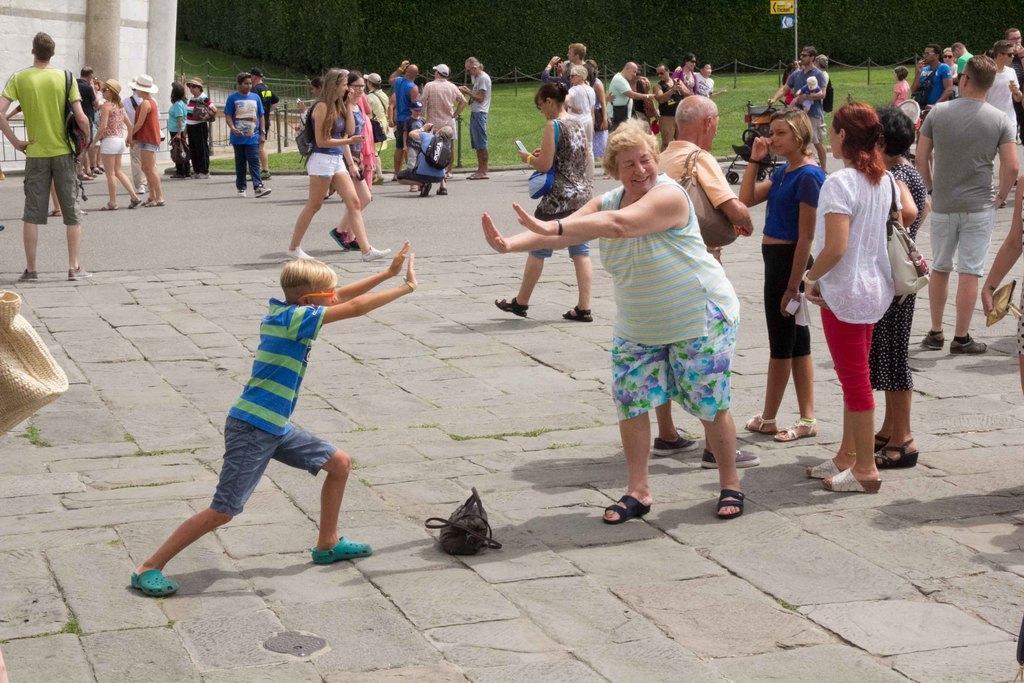Can you describe this image briefly? This image consists of many persons on the road. At the bottom, there is a bag. In the background, there are many trees. On the left, there is a building along with the fencing. 